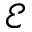<formula> <loc_0><loc_0><loc_500><loc_500>\mathcal { E }</formula> 